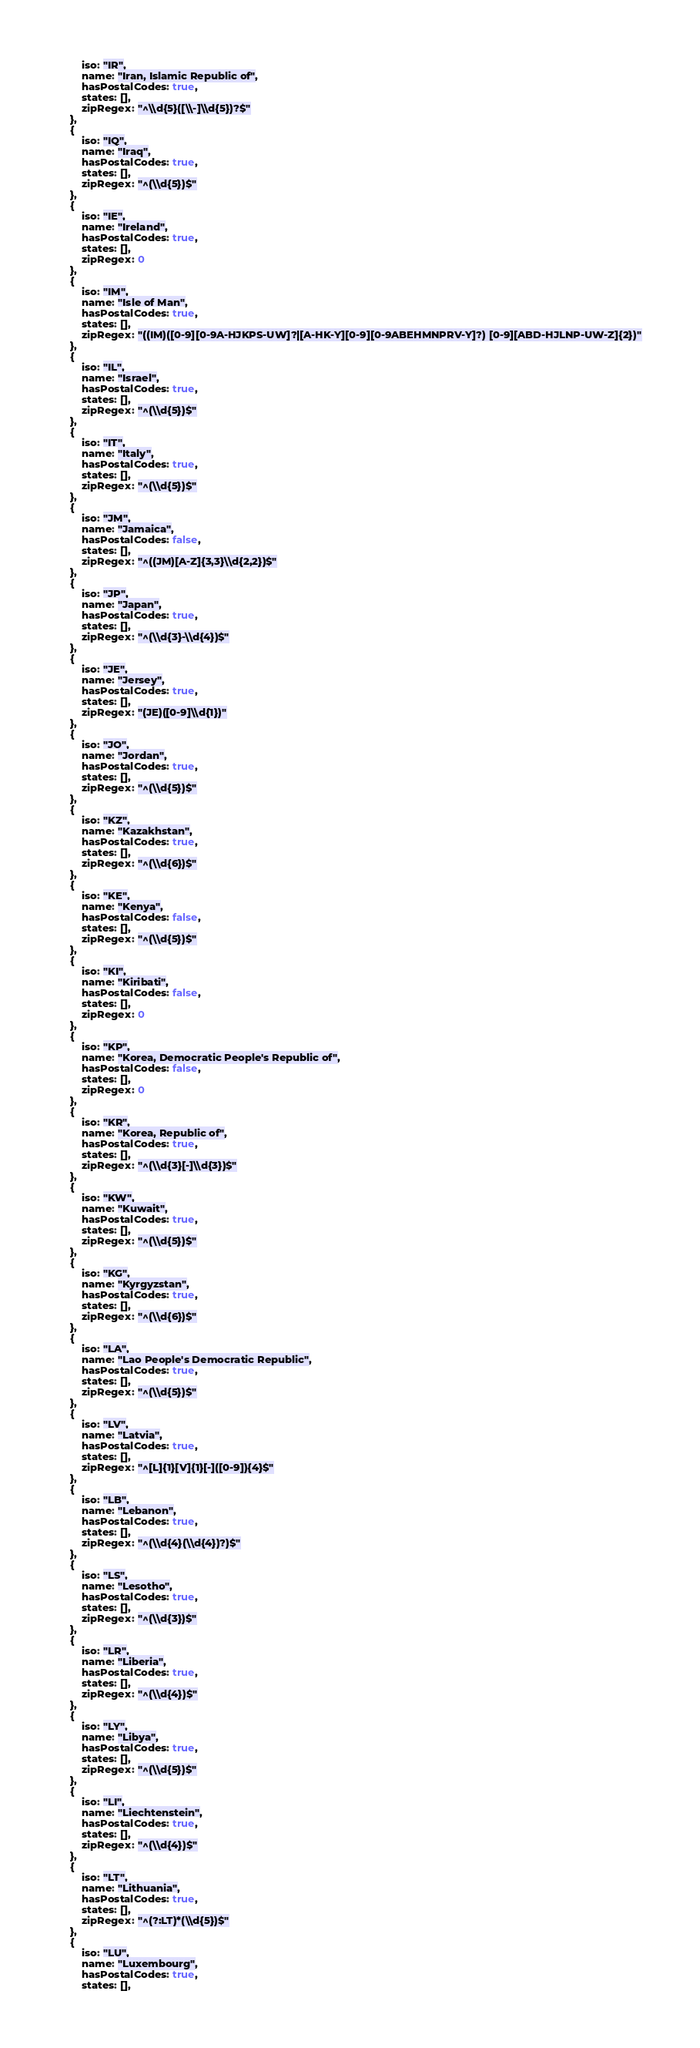<code> <loc_0><loc_0><loc_500><loc_500><_TypeScript_>        iso: "IR",
        name: "Iran, Islamic Republic of",
        hasPostalCodes: true,
        states: [],
        zipRegex: "^\\d{5}([\\-]\\d{5})?$"
    },
    {
        iso: "IQ",
        name: "Iraq",
        hasPostalCodes: true,
        states: [],
        zipRegex: "^(\\d{5})$"
    },
    {
        iso: "IE",
        name: "Ireland",
        hasPostalCodes: true,
        states: [],
        zipRegex: 0
    },
    {
        iso: "IM",
        name: "Isle of Man",
        hasPostalCodes: true,
        states: [],
        zipRegex: "((IM)([0-9][0-9A-HJKPS-UW]?|[A-HK-Y][0-9][0-9ABEHMNPRV-Y]?) [0-9][ABD-HJLNP-UW-Z]{2})"
    },
    {
        iso: "IL",
        name: "Israel",
        hasPostalCodes: true,
        states: [],
        zipRegex: "^(\\d{5})$"
    },
    {
        iso: "IT",
        name: "Italy",
        hasPostalCodes: true,
        states: [],
        zipRegex: "^(\\d{5})$"
    },
    {
        iso: "JM",
        name: "Jamaica",
        hasPostalCodes: false,
        states: [],
        zipRegex: "^((JM)[A-Z]{3,3}\\d{2,2})$"
    },
    {
        iso: "JP",
        name: "Japan",
        hasPostalCodes: true,
        states: [],
        zipRegex: "^(\\d{3}-\\d{4})$"
    },
    {
        iso: "JE",
        name: "Jersey",
        hasPostalCodes: true,
        states: [],
        zipRegex: "(JE)([0-9]\\d{1})"
    },
    {
        iso: "JO",
        name: "Jordan",
        hasPostalCodes: true,
        states: [],
        zipRegex: "^(\\d{5})$"
    },
    {
        iso: "KZ",
        name: "Kazakhstan",
        hasPostalCodes: true,
        states: [],
        zipRegex: "^(\\d{6})$"
    },
    {
        iso: "KE",
        name: "Kenya",
        hasPostalCodes: false,
        states: [],
        zipRegex: "^(\\d{5})$"
    },
    {
        iso: "KI",
        name: "Kiribati",
        hasPostalCodes: false,
        states: [],
        zipRegex: 0
    },
    {
        iso: "KP",
        name: "Korea, Democratic People's Republic of",
        hasPostalCodes: false,
        states: [],
        zipRegex: 0
    },
    {
        iso: "KR",
        name: "Korea, Republic of",
        hasPostalCodes: true,
        states: [],
        zipRegex: "^(\\d{3}[-]\\d{3})$"
    },
    {
        iso: "KW",
        name: "Kuwait",
        hasPostalCodes: true,
        states: [],
        zipRegex: "^(\\d{5})$"
    },
    {
        iso: "KG",
        name: "Kyrgyzstan",
        hasPostalCodes: true,
        states: [],
        zipRegex: "^(\\d{6})$"
    },
    {
        iso: "LA",
        name: "Lao People's Democratic Republic",
        hasPostalCodes: true,
        states: [],
        zipRegex: "^(\\d{5})$"
    },
    {
        iso: "LV",
        name: "Latvia",
        hasPostalCodes: true,
        states: [],
        zipRegex: "^[L]{1}[V]{1}[-]([0-9]){4}$"
    },
    {
        iso: "LB",
        name: "Lebanon",
        hasPostalCodes: true,
        states: [],
        zipRegex: "^(\\d{4}(\\d{4})?)$"
    },
    {
        iso: "LS",
        name: "Lesotho",
        hasPostalCodes: true,
        states: [],
        zipRegex: "^(\\d{3})$"
    },
    {
        iso: "LR",
        name: "Liberia",
        hasPostalCodes: true,
        states: [],
        zipRegex: "^(\\d{4})$"
    },
    {
        iso: "LY",
        name: "Libya",
        hasPostalCodes: true,
        states: [],
        zipRegex: "^(\\d{5})$"
    },
    {
        iso: "LI",
        name: "Liechtenstein",
        hasPostalCodes: true,
        states: [],
        zipRegex: "^(\\d{4})$"
    },
    {
        iso: "LT",
        name: "Lithuania",
        hasPostalCodes: true,
        states: [],
        zipRegex: "^(?:LT)*(\\d{5})$"
    },
    {
        iso: "LU",
        name: "Luxembourg",
        hasPostalCodes: true,
        states: [],</code> 